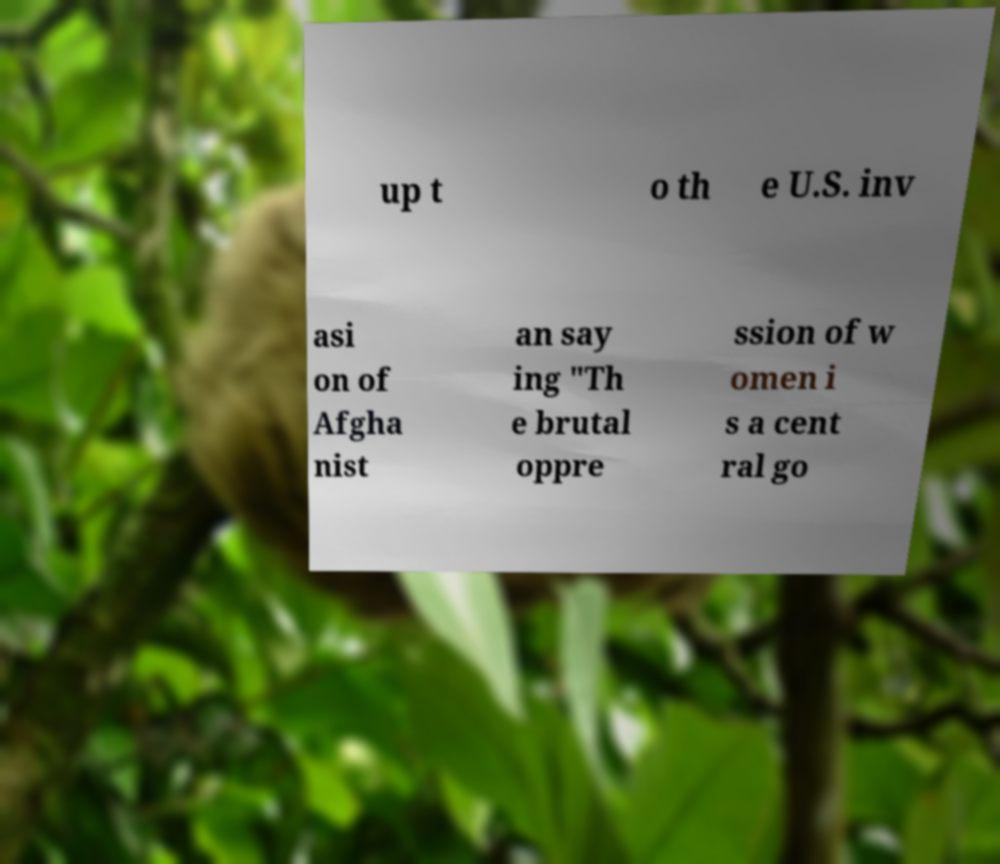There's text embedded in this image that I need extracted. Can you transcribe it verbatim? up t o th e U.S. inv asi on of Afgha nist an say ing "Th e brutal oppre ssion of w omen i s a cent ral go 